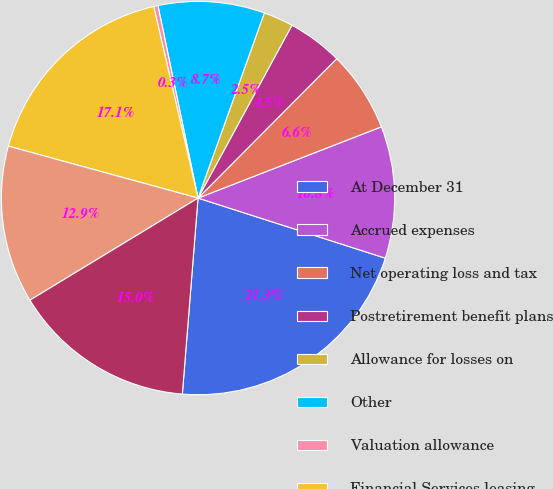Convert chart to OTSL. <chart><loc_0><loc_0><loc_500><loc_500><pie_chart><fcel>At December 31<fcel>Accrued expenses<fcel>Net operating loss and tax<fcel>Postretirement benefit plans<fcel>Allowance for losses on<fcel>Other<fcel>Valuation allowance<fcel>Financial Services leasing<fcel>Depreciation and amortization<fcel>Net deferred tax liability<nl><fcel>21.33%<fcel>10.84%<fcel>6.64%<fcel>4.54%<fcel>2.45%<fcel>8.74%<fcel>0.35%<fcel>17.13%<fcel>12.94%<fcel>15.04%<nl></chart> 